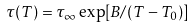<formula> <loc_0><loc_0><loc_500><loc_500>\tau ( T ) = \tau _ { \infty } \exp [ B / ( T - T _ { 0 } ) ]</formula> 